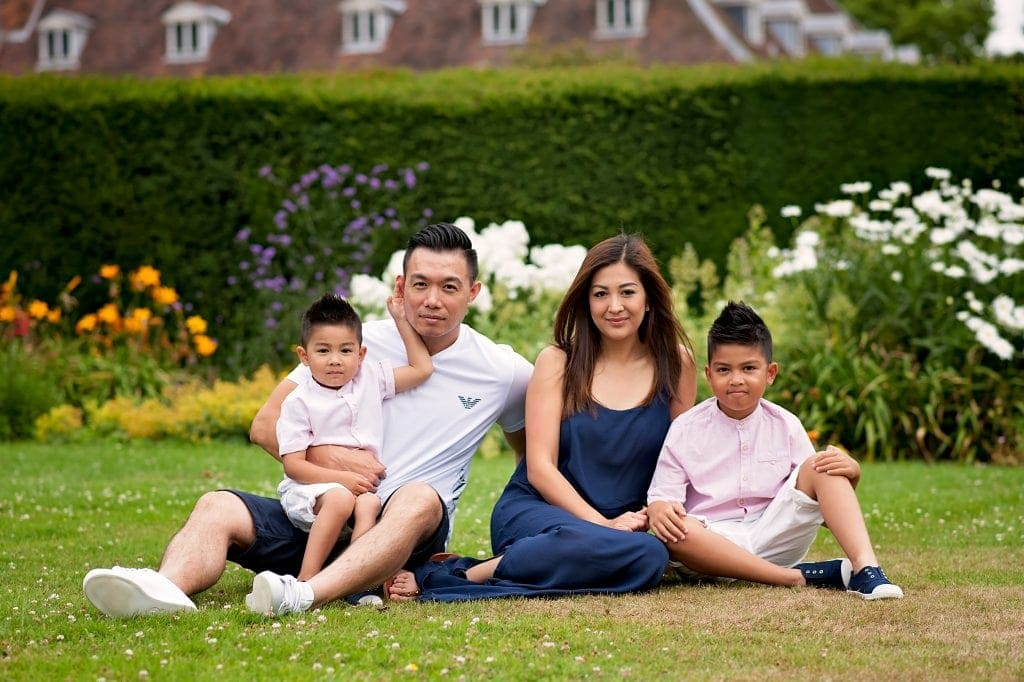How do the surroundings amplify the family's connection in the photograph? The lush, vibrant surroundings of the garden amplify the family's connection by providing a serene and picturesque backdrop. The colorful flowers and greenery create a tranquil environment that emphasizes the family's calm and happy demeanor. The natural setting evokes a sense of peace and togetherness, enhancing the overall warm and affectionate atmosphere conveyed by their body language and positioning. What time of year could this photo have been taken, and how does it influence the family’s attire? The photo was likely taken during the late spring or summer, as suggested by the vibrant and fully bloomed flowers, lush green grass, and bright ambient lighting. This season influences the family's attire; they are dressed in light, comfortable summer clothes suitable for warmer weather. The man is wearing shorts and a short-sleeved shirt, while the children are in short-sleeved shirts and shorts. The woman’s dress is also lightweight and casual. This choice of attire reflects a relaxed and warm family outing, further contributing to the overall cheerful and harmonious depiction of the family. Imagine the family went on an adventurous journey after this photo. Describe their most memorable experience. After the photo, the family embarked on a delightful and adventurous journey to a nearby nature reserve known for its scenic hiking trails and wildlife. Their most memorable experience was a thrilling encounter with a playful family of otters by a bubbling brook. The children were ecstatic, pointing and giggling as the otters splashed and darted through the water. The parents watched with content smiles, capturing the magical moment with their cameras. They spent the afternoon exploring hidden waterfalls, sharing a picnic by the water's edge, and collecting colorful stones as keepsakes. The day ended with a serene boat ride on the reserve's tranquil lake at sunset, the sky painted with hues of pink and orange, reflecting in the water. This spontaneous adventure brought the family even closer, creating a cherished memory that they would reminisce about for years to come. 